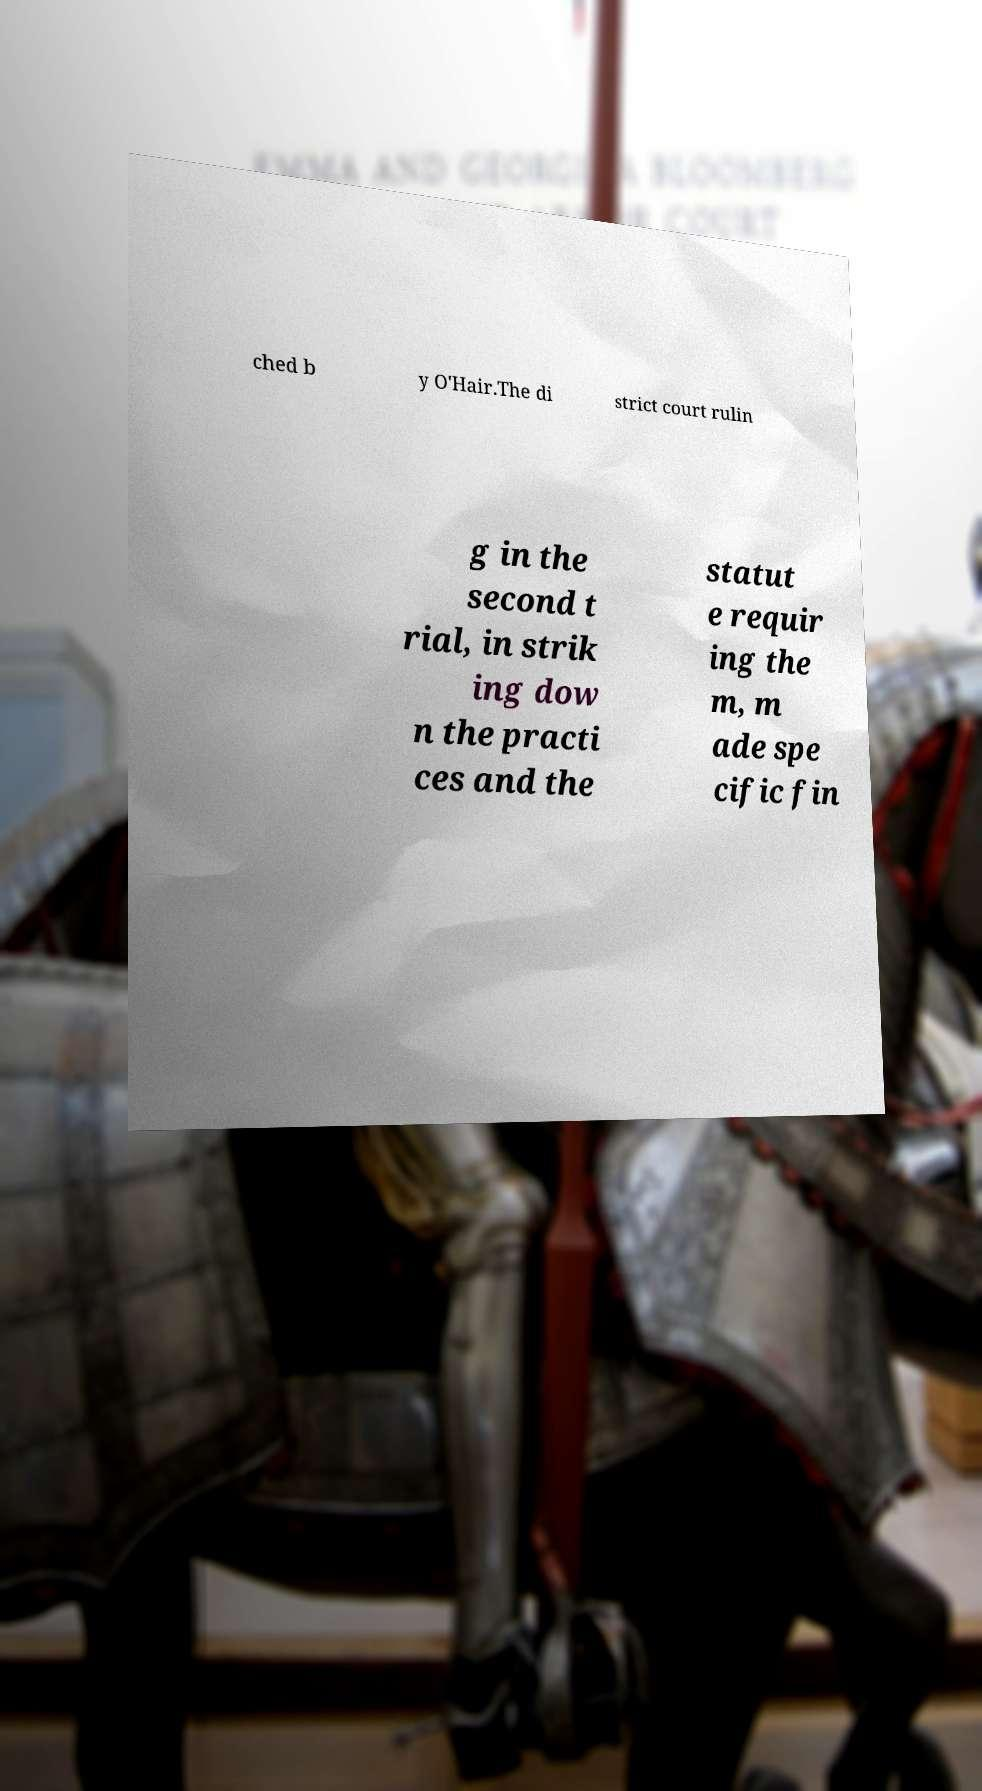Can you accurately transcribe the text from the provided image for me? ched b y O'Hair.The di strict court rulin g in the second t rial, in strik ing dow n the practi ces and the statut e requir ing the m, m ade spe cific fin 